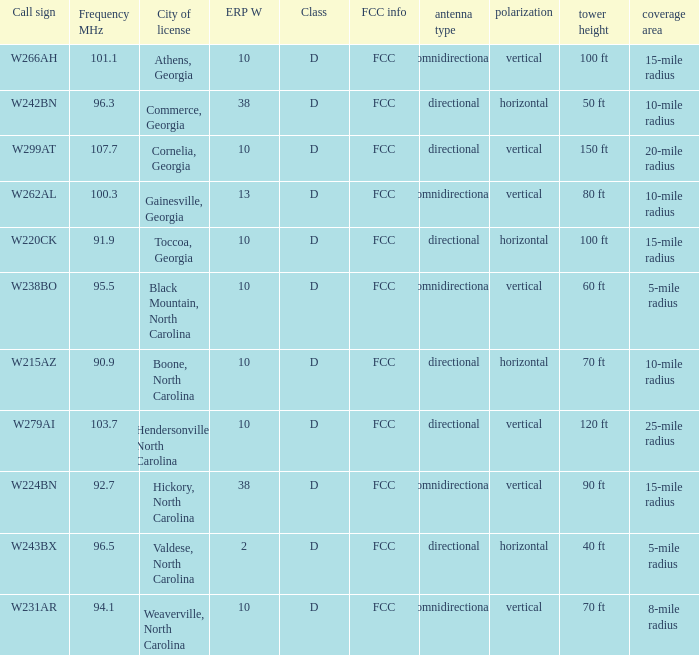What is the FCC frequency for the station w262al which has a Frequency MHz larger than 92.7? FCC. 